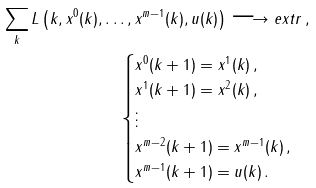Convert formula to latex. <formula><loc_0><loc_0><loc_500><loc_500>\sum _ { k } L \left ( k , x ^ { 0 } ( k ) , \dots , x ^ { m - 1 } ( k ) , u ( k ) \right ) \longrightarrow e x t r \, , \\ \begin{cases} x ^ { 0 } ( k + 1 ) = x ^ { 1 } ( k ) \, , \\ x ^ { 1 } ( k + 1 ) = x ^ { 2 } ( k ) \, , \\ \vdots \\ x ^ { m - 2 } ( k + 1 ) = x ^ { m - 1 } ( k ) \, , \\ x ^ { m - 1 } ( k + 1 ) = u ( k ) \, . \end{cases}</formula> 